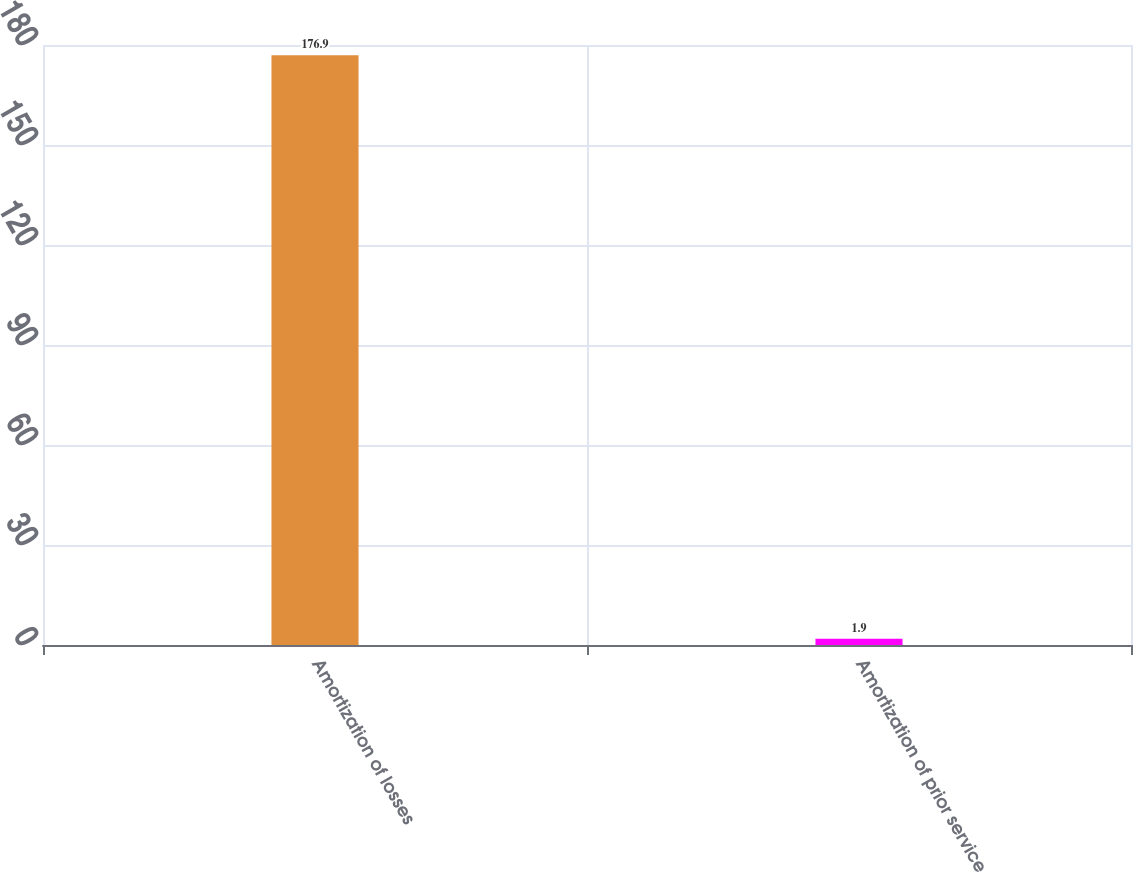Convert chart. <chart><loc_0><loc_0><loc_500><loc_500><bar_chart><fcel>Amortization of losses<fcel>Amortization of prior service<nl><fcel>176.9<fcel>1.9<nl></chart> 